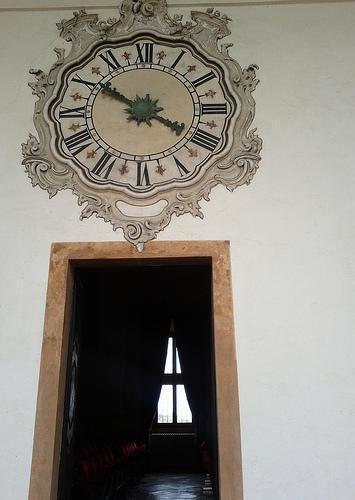How many clocks are there?
Give a very brief answer. 1. 